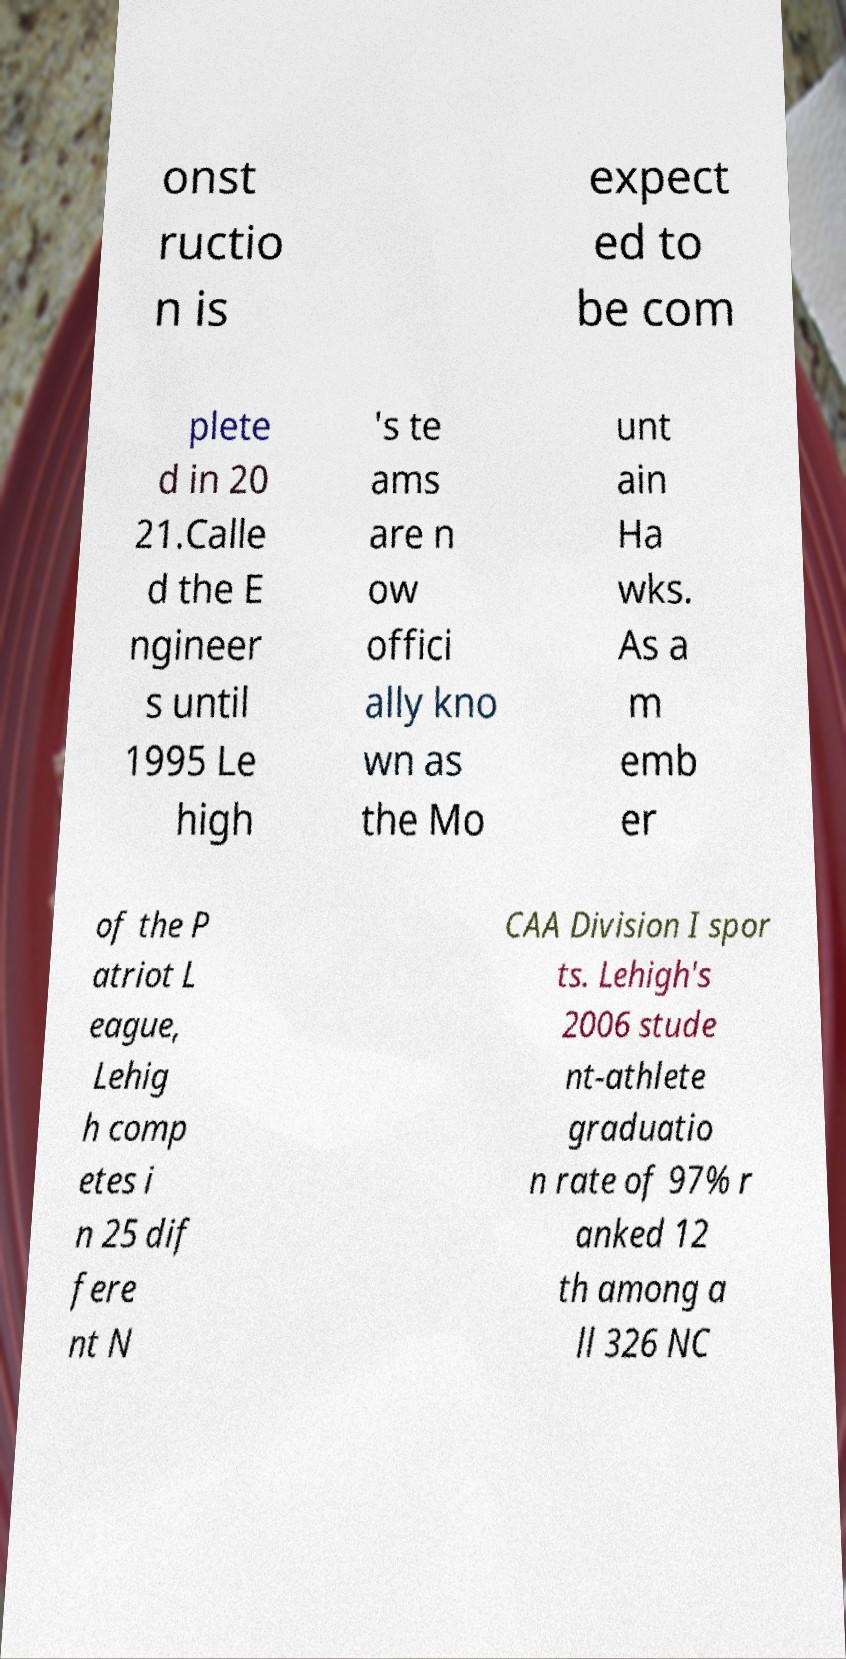Could you extract and type out the text from this image? onst ructio n is expect ed to be com plete d in 20 21.Calle d the E ngineer s until 1995 Le high 's te ams are n ow offici ally kno wn as the Mo unt ain Ha wks. As a m emb er of the P atriot L eague, Lehig h comp etes i n 25 dif fere nt N CAA Division I spor ts. Lehigh's 2006 stude nt-athlete graduatio n rate of 97% r anked 12 th among a ll 326 NC 